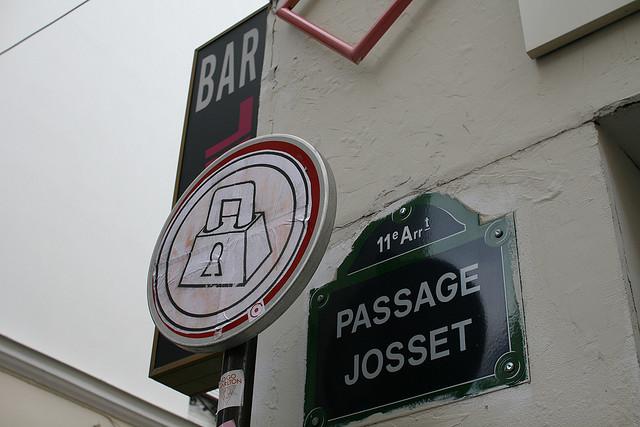Is there a skyscraper in the picture?
Be succinct. No. What kind of building is next to the sign?
Answer briefly. Bar. What is the writing on the top?
Concise answer only. Bar. Is this building old or new?
Short answer required. Old. What type of sign is this?
Concise answer only. Street sign. Can you get a drink close by?
Keep it brief. Yes. 